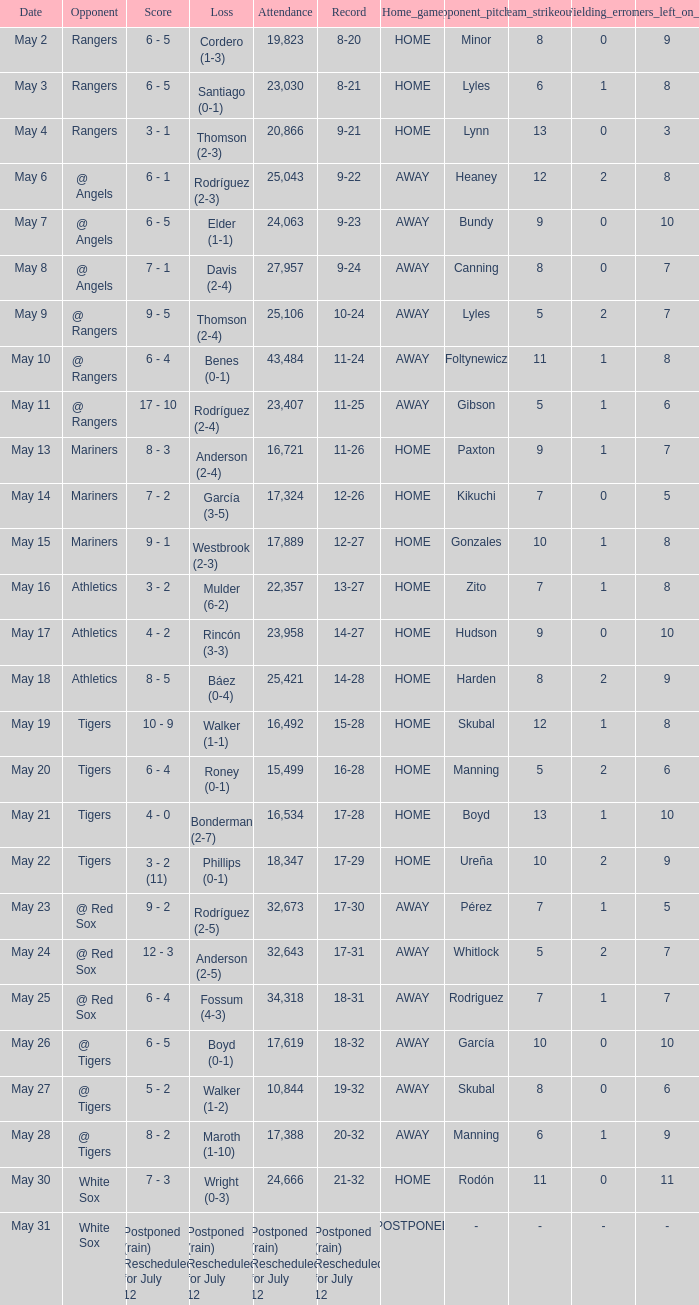What date did the Indians have a record of 14-28? May 18. 